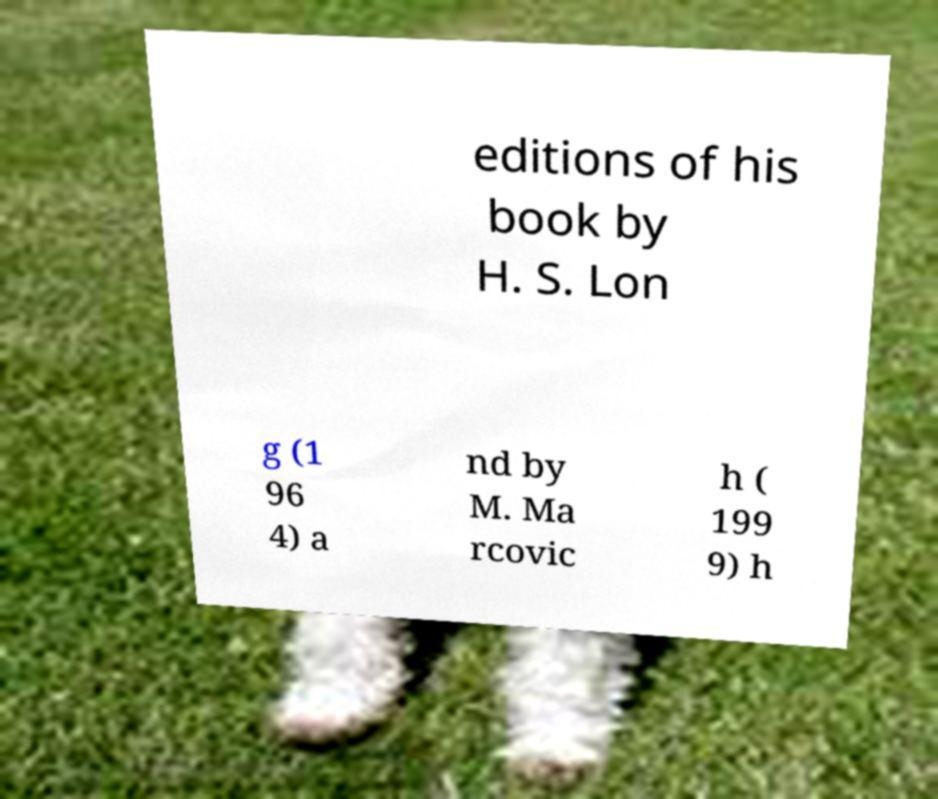There's text embedded in this image that I need extracted. Can you transcribe it verbatim? editions of his book by H. S. Lon g (1 96 4) a nd by M. Ma rcovic h ( 199 9) h 